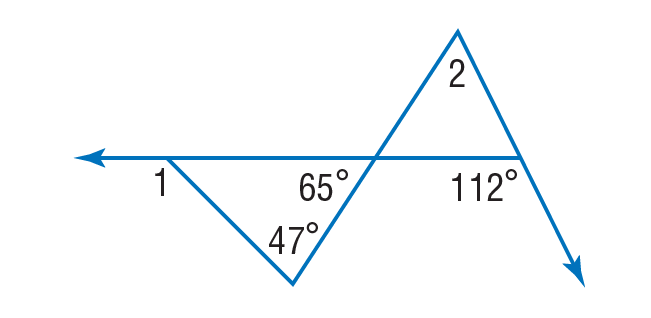Answer the mathemtical geometry problem and directly provide the correct option letter.
Question: Find \angle 1.
Choices: A: 47 B: 65 C: 112 D: 159 C 